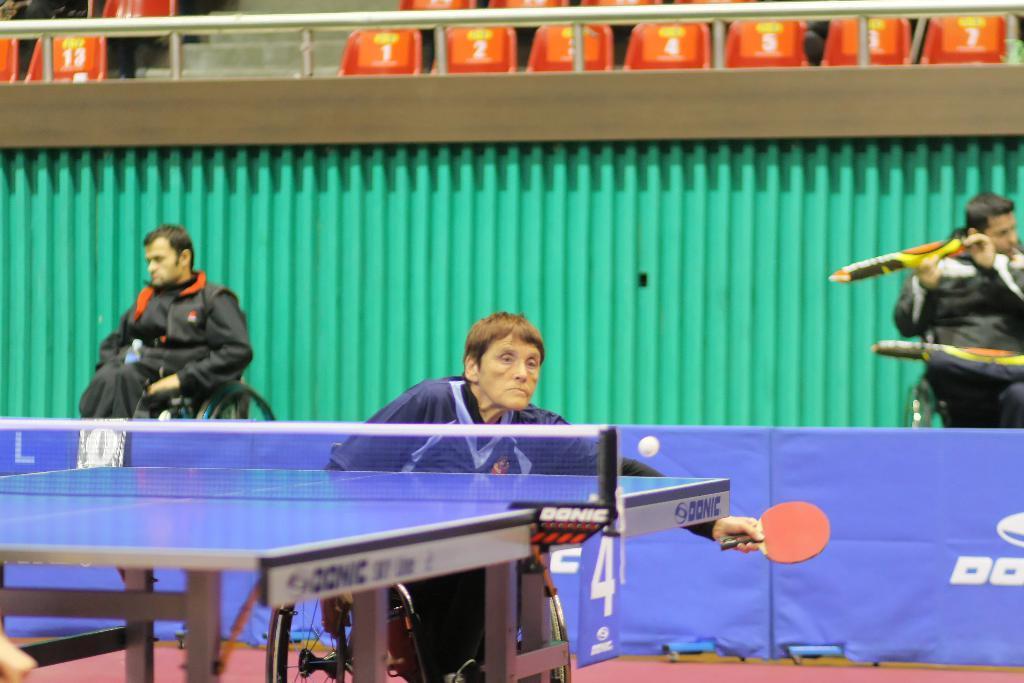How would you summarize this image in a sentence or two? This picture shows people seated on the wheelchair and woman seated on the wheelchair and playing table tennis 